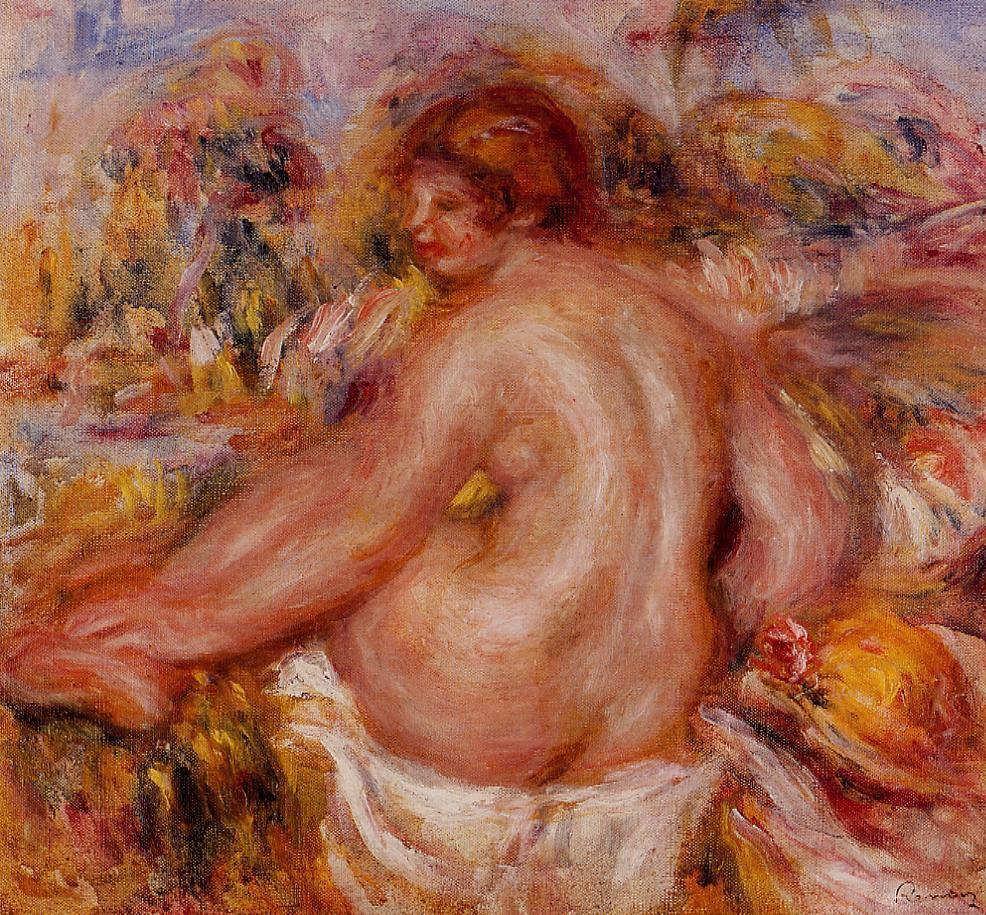What could be the significance of the red hair in this painting? The red hair of the woman in this painting could symbolize vitality and passion. Red is often associated with strong emotions and energy, and its vibrant hue contrasts beautifully with the softer tones of the surrounding flowers and background. This choice might be Renoir’s way of highlighting the woman’s presence and individuality, making her the focal point of the painting. The color red can also be associated with warmth and life, contributing to the overall feeling of warmth and tranquility in the work. 